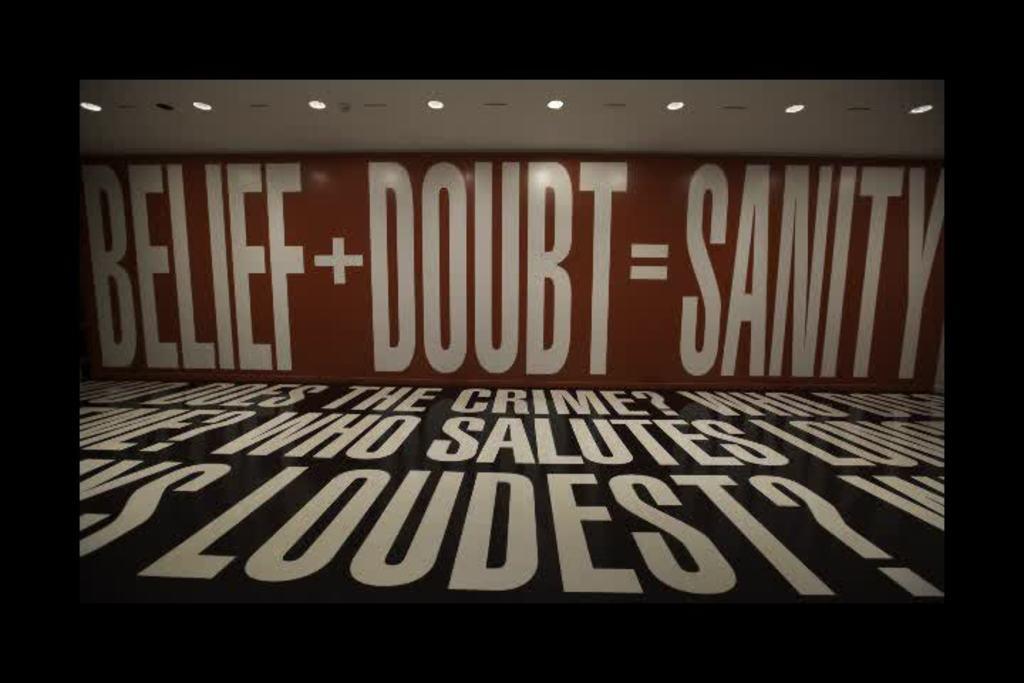What does the sign say equals sanity?
Make the answer very short. Belief + doubt. What is the word on the floor closest to you?
Offer a very short reply. Loudest. 